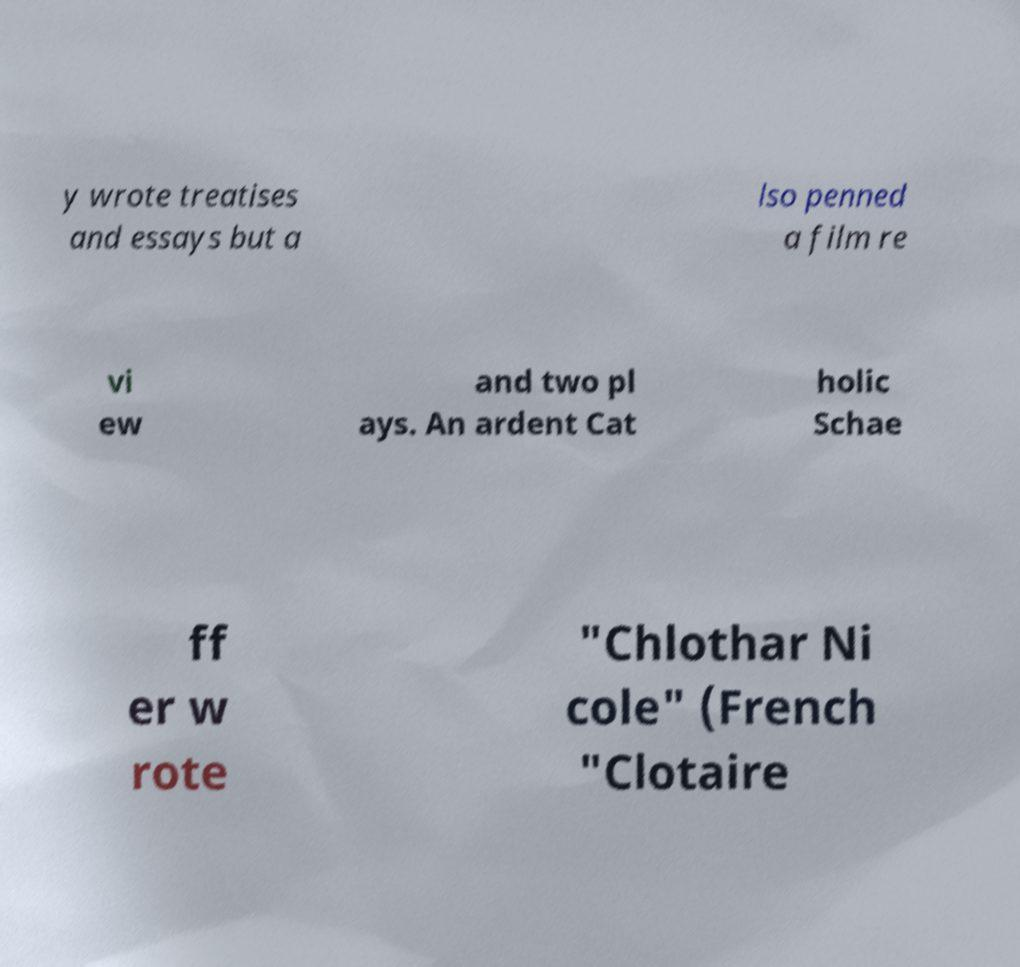For documentation purposes, I need the text within this image transcribed. Could you provide that? y wrote treatises and essays but a lso penned a film re vi ew and two pl ays. An ardent Cat holic Schae ff er w rote "Chlothar Ni cole" (French "Clotaire 